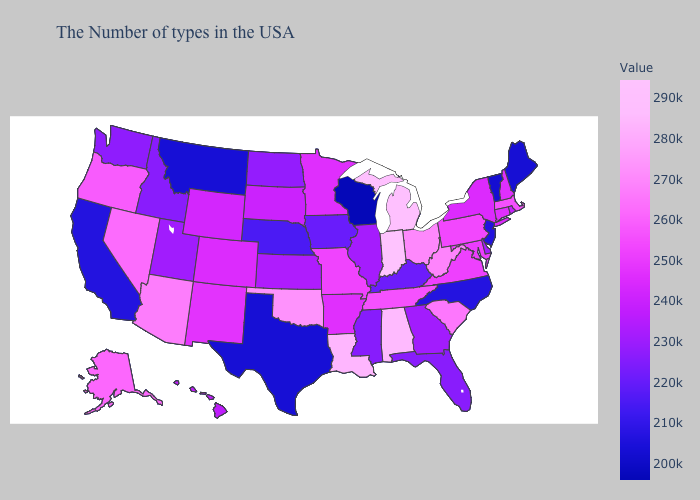Among the states that border Idaho , which have the highest value?
Quick response, please. Nevada. Which states have the lowest value in the Northeast?
Keep it brief. Vermont. Does California have the lowest value in the West?
Short answer required. No. Does Nebraska have a lower value than Maine?
Quick response, please. No. 